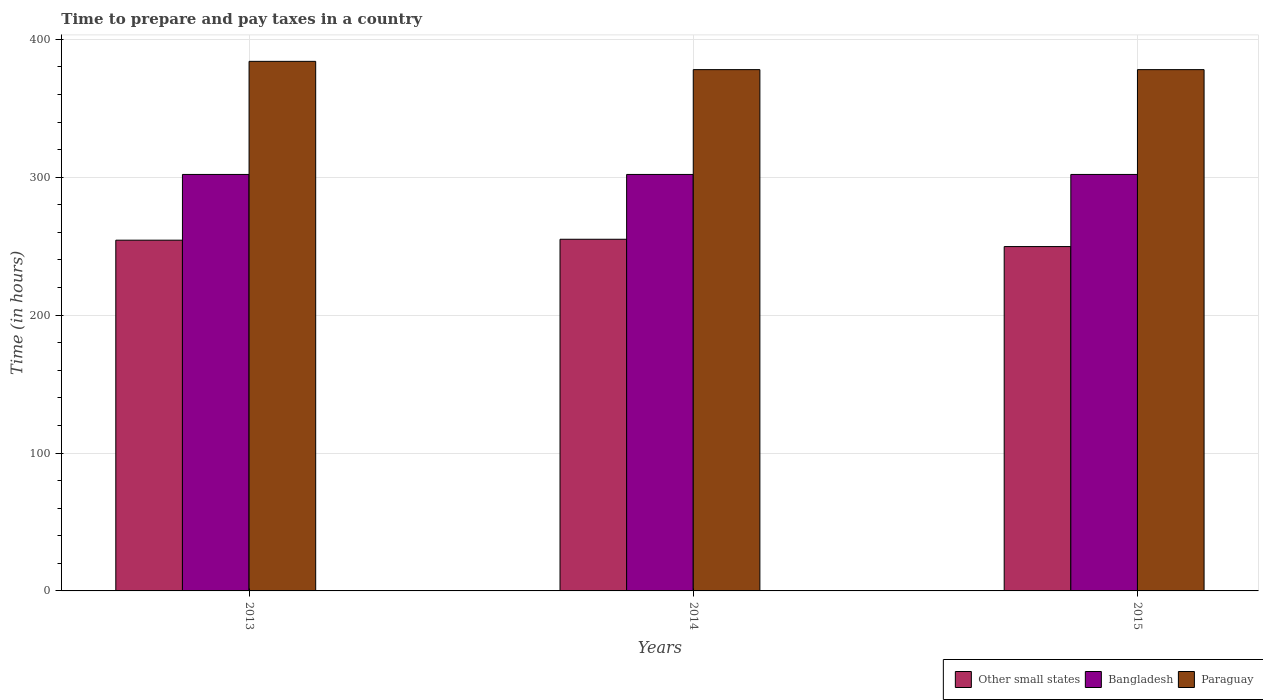How many groups of bars are there?
Keep it short and to the point. 3. How many bars are there on the 1st tick from the right?
Offer a very short reply. 3. What is the label of the 3rd group of bars from the left?
Make the answer very short. 2015. What is the number of hours required to prepare and pay taxes in Bangladesh in 2015?
Offer a very short reply. 302. Across all years, what is the maximum number of hours required to prepare and pay taxes in Bangladesh?
Give a very brief answer. 302. Across all years, what is the minimum number of hours required to prepare and pay taxes in Other small states?
Your response must be concise. 249.69. What is the total number of hours required to prepare and pay taxes in Other small states in the graph?
Keep it short and to the point. 759.03. What is the difference between the number of hours required to prepare and pay taxes in Other small states in 2013 and that in 2015?
Give a very brief answer. 4.64. What is the difference between the number of hours required to prepare and pay taxes in Bangladesh in 2015 and the number of hours required to prepare and pay taxes in Paraguay in 2014?
Ensure brevity in your answer.  -76. What is the average number of hours required to prepare and pay taxes in Bangladesh per year?
Your answer should be very brief. 302. In the year 2013, what is the difference between the number of hours required to prepare and pay taxes in Other small states and number of hours required to prepare and pay taxes in Bangladesh?
Make the answer very short. -47.67. What is the ratio of the number of hours required to prepare and pay taxes in Other small states in 2013 to that in 2014?
Provide a short and direct response. 1. Is the number of hours required to prepare and pay taxes in Paraguay in 2013 less than that in 2015?
Offer a terse response. No. Is the difference between the number of hours required to prepare and pay taxes in Other small states in 2013 and 2015 greater than the difference between the number of hours required to prepare and pay taxes in Bangladesh in 2013 and 2015?
Your answer should be very brief. Yes. In how many years, is the number of hours required to prepare and pay taxes in Other small states greater than the average number of hours required to prepare and pay taxes in Other small states taken over all years?
Keep it short and to the point. 2. Is the sum of the number of hours required to prepare and pay taxes in Bangladesh in 2014 and 2015 greater than the maximum number of hours required to prepare and pay taxes in Other small states across all years?
Offer a terse response. Yes. What does the 1st bar from the left in 2013 represents?
Your response must be concise. Other small states. What does the 2nd bar from the right in 2013 represents?
Your answer should be very brief. Bangladesh. How many years are there in the graph?
Give a very brief answer. 3. Are the values on the major ticks of Y-axis written in scientific E-notation?
Ensure brevity in your answer.  No. Does the graph contain grids?
Give a very brief answer. Yes. How are the legend labels stacked?
Offer a terse response. Horizontal. What is the title of the graph?
Give a very brief answer. Time to prepare and pay taxes in a country. Does "French Polynesia" appear as one of the legend labels in the graph?
Offer a very short reply. No. What is the label or title of the X-axis?
Give a very brief answer. Years. What is the label or title of the Y-axis?
Offer a very short reply. Time (in hours). What is the Time (in hours) in Other small states in 2013?
Ensure brevity in your answer.  254.33. What is the Time (in hours) in Bangladesh in 2013?
Give a very brief answer. 302. What is the Time (in hours) of Paraguay in 2013?
Offer a very short reply. 384. What is the Time (in hours) of Other small states in 2014?
Offer a terse response. 255. What is the Time (in hours) in Bangladesh in 2014?
Offer a very short reply. 302. What is the Time (in hours) in Paraguay in 2014?
Give a very brief answer. 378. What is the Time (in hours) in Other small states in 2015?
Keep it short and to the point. 249.69. What is the Time (in hours) in Bangladesh in 2015?
Offer a very short reply. 302. What is the Time (in hours) in Paraguay in 2015?
Your answer should be compact. 378. Across all years, what is the maximum Time (in hours) in Other small states?
Your answer should be compact. 255. Across all years, what is the maximum Time (in hours) of Bangladesh?
Make the answer very short. 302. Across all years, what is the maximum Time (in hours) in Paraguay?
Give a very brief answer. 384. Across all years, what is the minimum Time (in hours) of Other small states?
Provide a succinct answer. 249.69. Across all years, what is the minimum Time (in hours) of Bangladesh?
Give a very brief answer. 302. Across all years, what is the minimum Time (in hours) of Paraguay?
Ensure brevity in your answer.  378. What is the total Time (in hours) of Other small states in the graph?
Keep it short and to the point. 759.03. What is the total Time (in hours) in Bangladesh in the graph?
Keep it short and to the point. 906. What is the total Time (in hours) in Paraguay in the graph?
Your response must be concise. 1140. What is the difference between the Time (in hours) in Bangladesh in 2013 and that in 2014?
Offer a very short reply. 0. What is the difference between the Time (in hours) of Paraguay in 2013 and that in 2014?
Make the answer very short. 6. What is the difference between the Time (in hours) of Other small states in 2013 and that in 2015?
Offer a very short reply. 4.64. What is the difference between the Time (in hours) of Other small states in 2014 and that in 2015?
Make the answer very short. 5.31. What is the difference between the Time (in hours) in Other small states in 2013 and the Time (in hours) in Bangladesh in 2014?
Ensure brevity in your answer.  -47.67. What is the difference between the Time (in hours) of Other small states in 2013 and the Time (in hours) of Paraguay in 2014?
Offer a terse response. -123.67. What is the difference between the Time (in hours) of Bangladesh in 2013 and the Time (in hours) of Paraguay in 2014?
Make the answer very short. -76. What is the difference between the Time (in hours) in Other small states in 2013 and the Time (in hours) in Bangladesh in 2015?
Give a very brief answer. -47.67. What is the difference between the Time (in hours) of Other small states in 2013 and the Time (in hours) of Paraguay in 2015?
Offer a terse response. -123.67. What is the difference between the Time (in hours) in Bangladesh in 2013 and the Time (in hours) in Paraguay in 2015?
Provide a succinct answer. -76. What is the difference between the Time (in hours) of Other small states in 2014 and the Time (in hours) of Bangladesh in 2015?
Your answer should be compact. -47. What is the difference between the Time (in hours) in Other small states in 2014 and the Time (in hours) in Paraguay in 2015?
Your answer should be very brief. -123. What is the difference between the Time (in hours) of Bangladesh in 2014 and the Time (in hours) of Paraguay in 2015?
Your answer should be very brief. -76. What is the average Time (in hours) in Other small states per year?
Your answer should be very brief. 253.01. What is the average Time (in hours) of Bangladesh per year?
Give a very brief answer. 302. What is the average Time (in hours) of Paraguay per year?
Keep it short and to the point. 380. In the year 2013, what is the difference between the Time (in hours) in Other small states and Time (in hours) in Bangladesh?
Provide a succinct answer. -47.67. In the year 2013, what is the difference between the Time (in hours) in Other small states and Time (in hours) in Paraguay?
Provide a short and direct response. -129.67. In the year 2013, what is the difference between the Time (in hours) of Bangladesh and Time (in hours) of Paraguay?
Your answer should be compact. -82. In the year 2014, what is the difference between the Time (in hours) of Other small states and Time (in hours) of Bangladesh?
Offer a very short reply. -47. In the year 2014, what is the difference between the Time (in hours) of Other small states and Time (in hours) of Paraguay?
Offer a very short reply. -123. In the year 2014, what is the difference between the Time (in hours) of Bangladesh and Time (in hours) of Paraguay?
Give a very brief answer. -76. In the year 2015, what is the difference between the Time (in hours) of Other small states and Time (in hours) of Bangladesh?
Ensure brevity in your answer.  -52.31. In the year 2015, what is the difference between the Time (in hours) in Other small states and Time (in hours) in Paraguay?
Provide a succinct answer. -128.31. In the year 2015, what is the difference between the Time (in hours) of Bangladesh and Time (in hours) of Paraguay?
Ensure brevity in your answer.  -76. What is the ratio of the Time (in hours) of Other small states in 2013 to that in 2014?
Ensure brevity in your answer.  1. What is the ratio of the Time (in hours) of Bangladesh in 2013 to that in 2014?
Keep it short and to the point. 1. What is the ratio of the Time (in hours) of Paraguay in 2013 to that in 2014?
Give a very brief answer. 1.02. What is the ratio of the Time (in hours) in Other small states in 2013 to that in 2015?
Provide a short and direct response. 1.02. What is the ratio of the Time (in hours) in Bangladesh in 2013 to that in 2015?
Make the answer very short. 1. What is the ratio of the Time (in hours) of Paraguay in 2013 to that in 2015?
Your response must be concise. 1.02. What is the ratio of the Time (in hours) of Other small states in 2014 to that in 2015?
Give a very brief answer. 1.02. What is the ratio of the Time (in hours) in Paraguay in 2014 to that in 2015?
Your answer should be very brief. 1. What is the difference between the highest and the second highest Time (in hours) in Other small states?
Offer a terse response. 0.67. What is the difference between the highest and the lowest Time (in hours) of Other small states?
Provide a succinct answer. 5.31. 